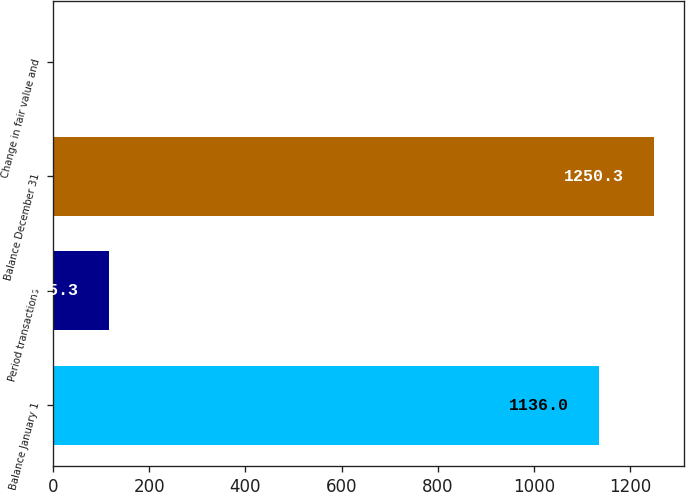Convert chart. <chart><loc_0><loc_0><loc_500><loc_500><bar_chart><fcel>Balance January 1<fcel>Period transactions<fcel>Balance December 31<fcel>Change in fair value and<nl><fcel>1136<fcel>115.3<fcel>1250.3<fcel>1<nl></chart> 